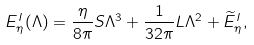Convert formula to latex. <formula><loc_0><loc_0><loc_500><loc_500>E ^ { I } _ { \eta } ( \Lambda ) = \frac { \eta } { 8 \pi } S \Lambda ^ { 3 } + \frac { 1 } { 3 2 \pi } L \Lambda ^ { 2 } + \widetilde { E } ^ { I } _ { \eta } ,</formula> 